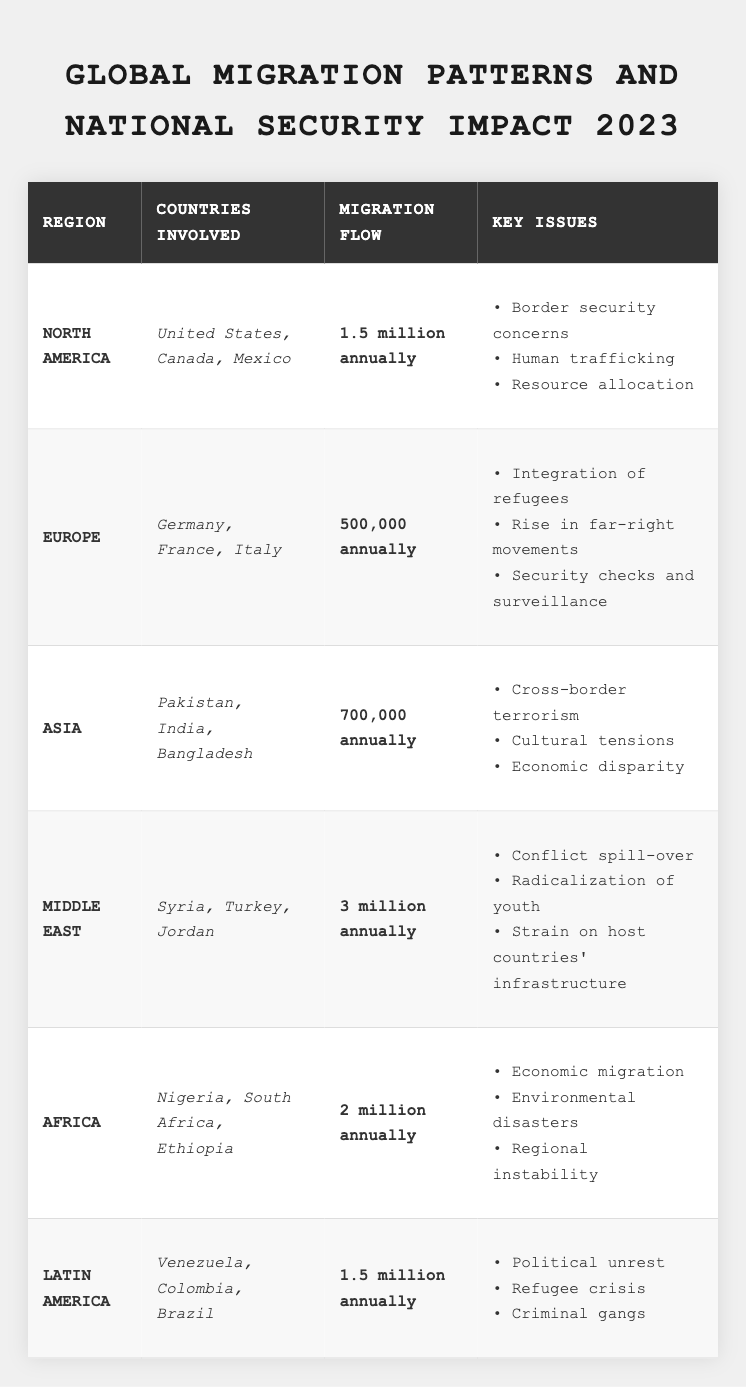What is the migration flow from the Middle East? The table shows that the migration flow from the Middle East is indicated as "3 million annually."
Answer: 3 million annually Which region has the highest migration flow? According to the table, the Middle East has the highest migration flow at 3 million annually, more than any other region listed.
Answer: Middle East How many countries are involved in migration in North America? The table lists three countries involved in migration in North America: the United States, Canada, and Mexico. Therefore, there are 3 countries in total.
Answer: 3 countries What are the key issues related to migration in Europe? The table outlines three key issues for Europe: integration of refugees, rise in far-right movements, and security checks and surveillance.
Answer: Integration of refugees, rise in far-right movements, security checks and surveillance What is the total annual migration flow from Africa and Asia combined? The migration flow from Africa is 2 million, and from Asia, it is 700,000. Adding these gives: 2 million + 700,000 = 2.7 million.
Answer: 2.7 million annually Is the migration flow from Latin America equal to that from North America? The table states that the migration flow from Latin America is 1.5 million annually, which is exactly the same as that from North America. Therefore, the statement is true.
Answer: Yes Which region has the lowest migration flow? From the table, Europe shows the lowest migration flow with 500,000 annually, which is the smallest number when compared to the other regions.
Answer: Europe How many key issues are listed for migration in the Middle East? The table specifies three key issues for the Middle East: conflict spill-over, radicalization of youth, and strain on host countries' infrastructure. Thus, there are three key issues listed.
Answer: 3 key issues What kind of migration issues is reported in Africa? The table lists three issues attributed to migration in Africa: economic migration, environmental disasters, and regional instability.
Answer: Economic migration, environmental disasters, regional instability How does cultural tension feature in migration patterns? The table indicates that cultural tensions are a key issue associated with migration in Asia, specifically reflecting challenges that arise from the influx of migrants into culturally distinct regions.
Answer: Cultural tensions in Asia 